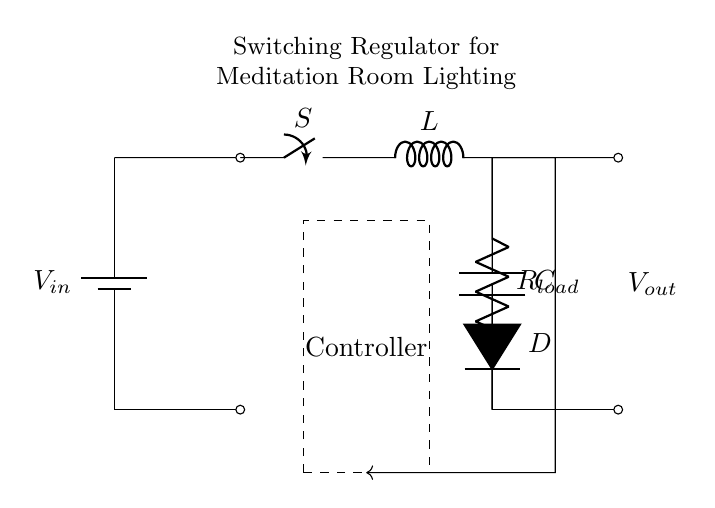What type of control component is used in this circuit? The control component is labeled as "Controller" in the dashed box, which indicates the part of the circuit responsible for regulating the output voltage based on feedback.
Answer: Controller What is the load in this circuit? The load is represented by "R_load" and is connected to the output of the regulator, which means it represents the device or circuit that consumes power from the regulator.
Answer: R_load Where is the inductor located? The inductor is labeled "L" and is situated between the switch "S" and the diode "D", serving as a key energy storage element in the switching regulator.
Answer: Between the switch and diode What is the function of the diode in this circuit? The diode labeled "D" allows current to flow only in one direction, preventing backflow when the switch is off, which is crucial for maintaining energy transfer to the load during the switching cycle.
Answer: Prevents backflow What is the voltage input symbolized in the circuit? The input voltage is denoted as "V_in" at the battery symbol in the top left corner of the circuit, indicating the source voltage supplied to the regulator.
Answer: V_in How does feedback connect to the controller? The feedback is represented by a line connecting the output of the load to the controller, allowing it to compare the actual output voltage with the desired value for regulation.
Answer: By a short feedback line What role does the capacitor play in this circuit? The capacitor labeled "C" smooths out voltage fluctuations at the output, providing a stable voltage to the load by storing and releasing energy as needed.
Answer: Smooths output voltage 